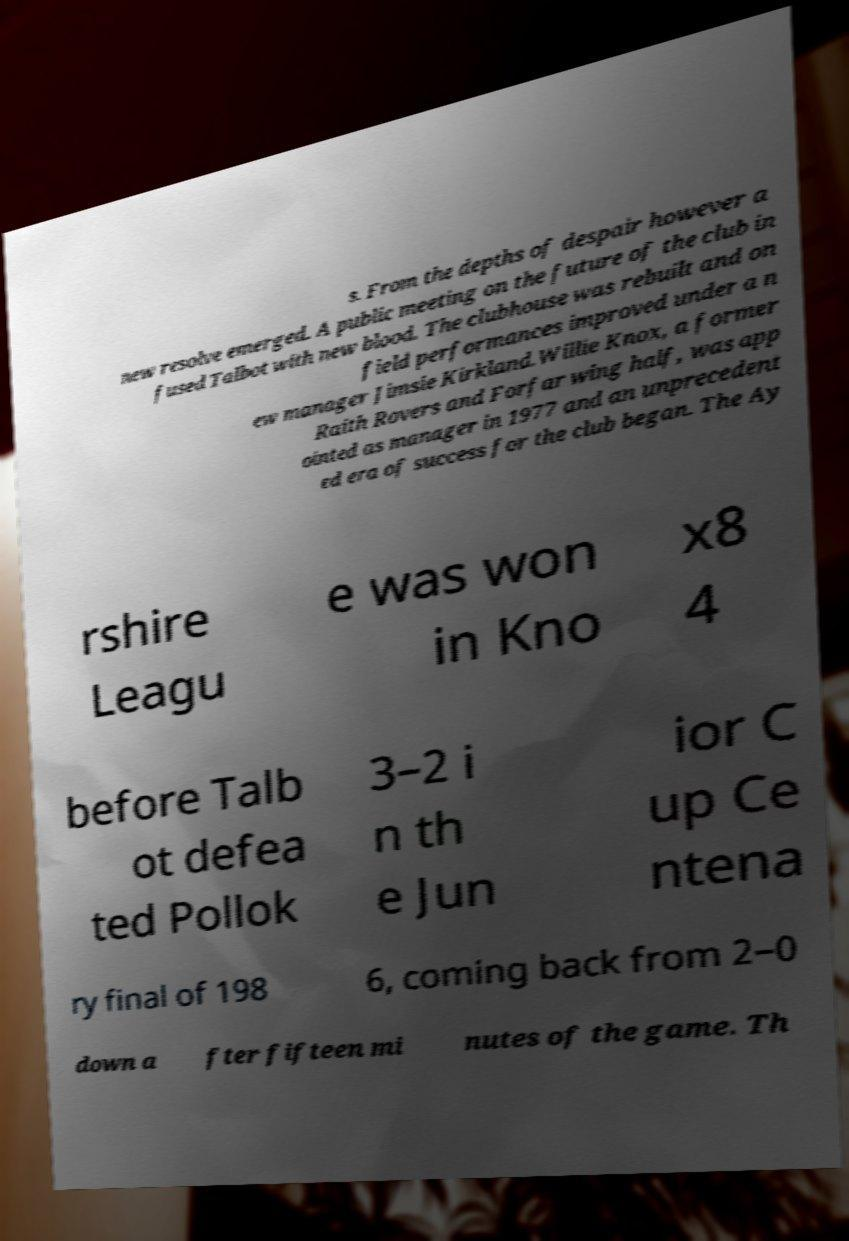Please read and relay the text visible in this image. What does it say? s. From the depths of despair however a new resolve emerged. A public meeting on the future of the club in fused Talbot with new blood. The clubhouse was rebuilt and on field performances improved under a n ew manager Jimsie Kirkland.Willie Knox, a former Raith Rovers and Forfar wing half, was app ointed as manager in 1977 and an unprecedent ed era of success for the club began. The Ay rshire Leagu e was won in Kno x8 4 before Talb ot defea ted Pollok 3–2 i n th e Jun ior C up Ce ntena ry final of 198 6, coming back from 2–0 down a fter fifteen mi nutes of the game. Th 